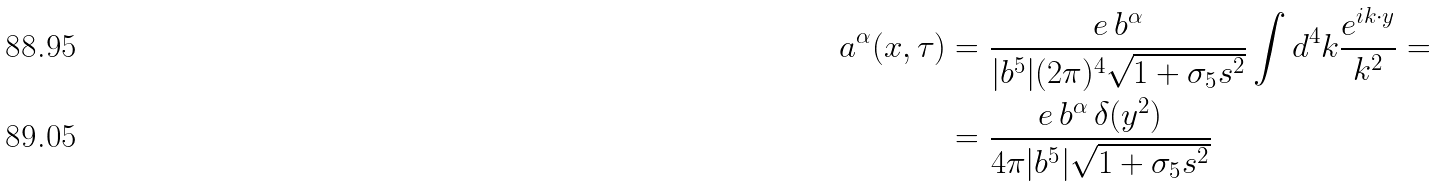<formula> <loc_0><loc_0><loc_500><loc_500>a ^ { \alpha } ( x , \tau ) & = \frac { e \, b ^ { \alpha } } { | b ^ { 5 } | ( 2 \pi ) ^ { 4 } \sqrt { 1 + \sigma _ { 5 } s ^ { 2 } } } \int d ^ { 4 } k \frac { e ^ { i k \cdot y } } { k ^ { 2 } } = \\ & = \frac { e \, b ^ { \alpha } \, \delta ( y ^ { 2 } ) } { 4 \pi | b ^ { 5 } | \sqrt { 1 + \sigma _ { 5 } s ^ { 2 } } }</formula> 